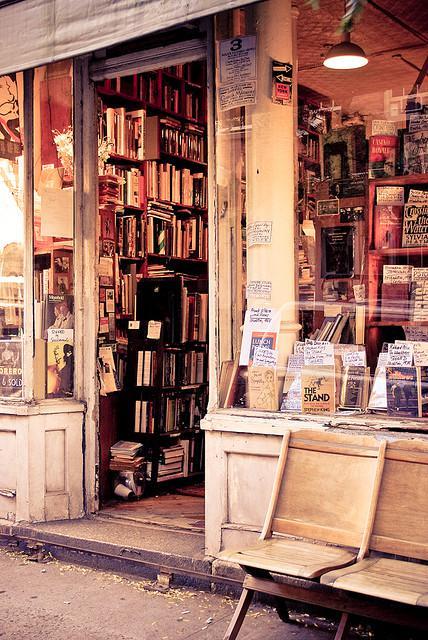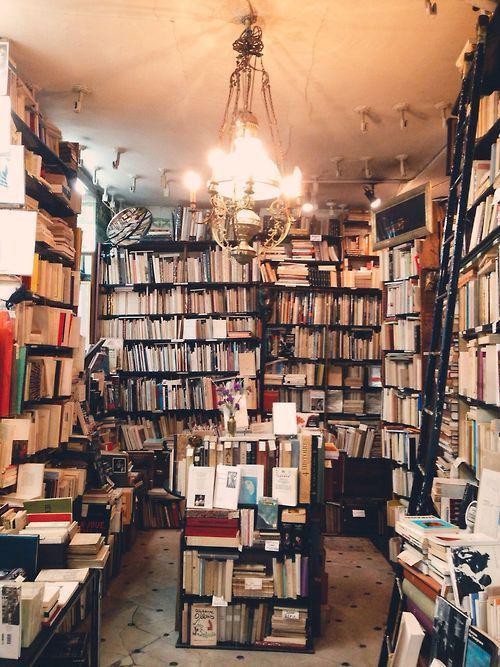The first image is the image on the left, the second image is the image on the right. For the images shown, is this caption "There is only an image of the inside of a bookstore." true? Answer yes or no. No. The first image is the image on the left, the second image is the image on the right. Considering the images on both sides, is "To the left, there are some chairs that people can use for sitting." valid? Answer yes or no. Yes. 